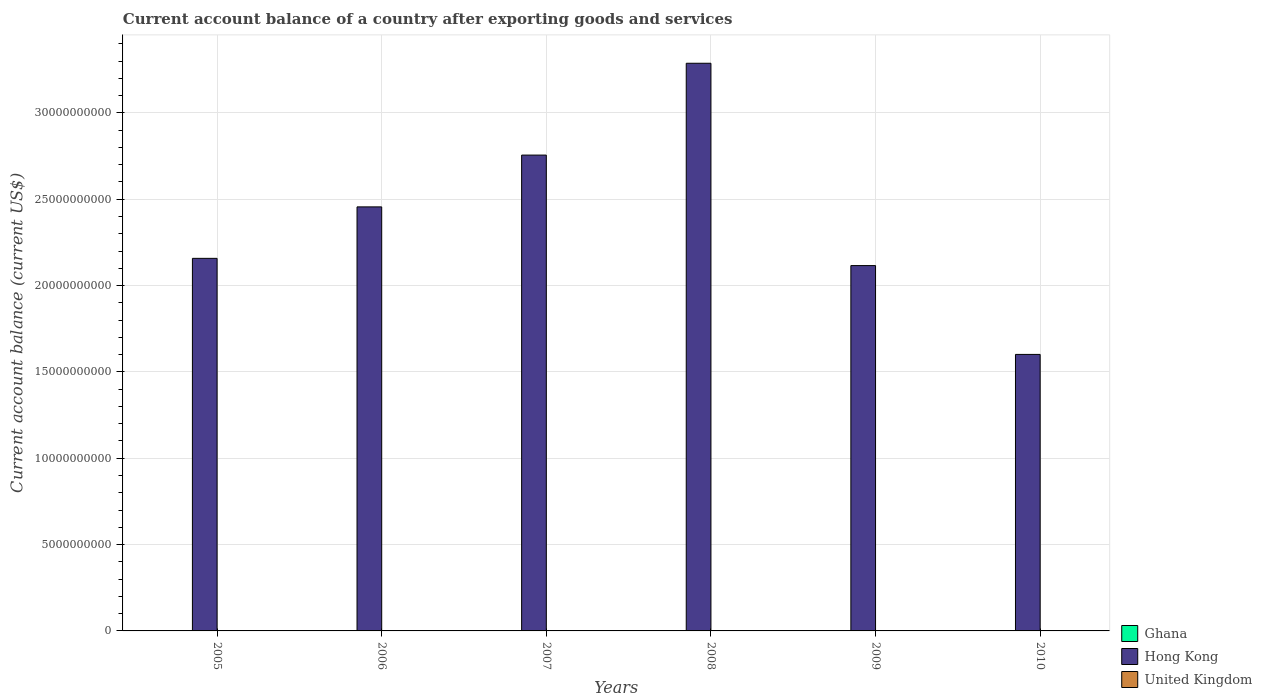How many different coloured bars are there?
Your response must be concise. 1. How many bars are there on the 6th tick from the right?
Your response must be concise. 1. What is the label of the 4th group of bars from the left?
Make the answer very short. 2008. What is the account balance in Hong Kong in 2005?
Your answer should be very brief. 2.16e+1. Across all years, what is the maximum account balance in Hong Kong?
Make the answer very short. 3.29e+1. Across all years, what is the minimum account balance in Hong Kong?
Provide a succinct answer. 1.60e+1. What is the total account balance in Hong Kong in the graph?
Provide a succinct answer. 1.44e+11. What is the difference between the account balance in Hong Kong in 2007 and that in 2009?
Offer a terse response. 6.40e+09. What is the average account balance in Hong Kong per year?
Provide a succinct answer. 2.40e+1. In how many years, is the account balance in Hong Kong greater than 33000000000 US$?
Make the answer very short. 0. What is the ratio of the account balance in Hong Kong in 2005 to that in 2009?
Provide a succinct answer. 1.02. Is the account balance in Hong Kong in 2005 less than that in 2009?
Provide a short and direct response. No. What is the difference between the highest and the second highest account balance in Hong Kong?
Provide a succinct answer. 5.32e+09. What is the difference between the highest and the lowest account balance in Hong Kong?
Offer a very short reply. 1.69e+1. In how many years, is the account balance in Ghana greater than the average account balance in Ghana taken over all years?
Make the answer very short. 0. Is the sum of the account balance in Hong Kong in 2006 and 2009 greater than the maximum account balance in Ghana across all years?
Provide a short and direct response. Yes. Is it the case that in every year, the sum of the account balance in Hong Kong and account balance in United Kingdom is greater than the account balance in Ghana?
Keep it short and to the point. Yes. Are all the bars in the graph horizontal?
Your answer should be compact. No. How many years are there in the graph?
Your response must be concise. 6. What is the difference between two consecutive major ticks on the Y-axis?
Your answer should be very brief. 5.00e+09. Does the graph contain any zero values?
Your answer should be compact. Yes. Does the graph contain grids?
Provide a succinct answer. Yes. Where does the legend appear in the graph?
Keep it short and to the point. Bottom right. How many legend labels are there?
Ensure brevity in your answer.  3. How are the legend labels stacked?
Keep it short and to the point. Vertical. What is the title of the graph?
Offer a terse response. Current account balance of a country after exporting goods and services. What is the label or title of the Y-axis?
Keep it short and to the point. Current account balance (current US$). What is the Current account balance (current US$) in Hong Kong in 2005?
Offer a very short reply. 2.16e+1. What is the Current account balance (current US$) of United Kingdom in 2005?
Provide a short and direct response. 0. What is the Current account balance (current US$) in Ghana in 2006?
Provide a succinct answer. 0. What is the Current account balance (current US$) in Hong Kong in 2006?
Offer a terse response. 2.46e+1. What is the Current account balance (current US$) in Hong Kong in 2007?
Your answer should be very brief. 2.76e+1. What is the Current account balance (current US$) of United Kingdom in 2007?
Make the answer very short. 0. What is the Current account balance (current US$) of Ghana in 2008?
Provide a short and direct response. 0. What is the Current account balance (current US$) in Hong Kong in 2008?
Your response must be concise. 3.29e+1. What is the Current account balance (current US$) in Hong Kong in 2009?
Keep it short and to the point. 2.12e+1. What is the Current account balance (current US$) of United Kingdom in 2009?
Your answer should be compact. 0. What is the Current account balance (current US$) in Ghana in 2010?
Offer a very short reply. 0. What is the Current account balance (current US$) of Hong Kong in 2010?
Your answer should be very brief. 1.60e+1. What is the Current account balance (current US$) in United Kingdom in 2010?
Ensure brevity in your answer.  0. Across all years, what is the maximum Current account balance (current US$) of Hong Kong?
Your answer should be compact. 3.29e+1. Across all years, what is the minimum Current account balance (current US$) in Hong Kong?
Ensure brevity in your answer.  1.60e+1. What is the total Current account balance (current US$) in Ghana in the graph?
Keep it short and to the point. 0. What is the total Current account balance (current US$) in Hong Kong in the graph?
Your answer should be very brief. 1.44e+11. What is the difference between the Current account balance (current US$) of Hong Kong in 2005 and that in 2006?
Provide a succinct answer. -2.98e+09. What is the difference between the Current account balance (current US$) of Hong Kong in 2005 and that in 2007?
Make the answer very short. -5.98e+09. What is the difference between the Current account balance (current US$) in Hong Kong in 2005 and that in 2008?
Provide a succinct answer. -1.13e+1. What is the difference between the Current account balance (current US$) in Hong Kong in 2005 and that in 2009?
Ensure brevity in your answer.  4.19e+08. What is the difference between the Current account balance (current US$) in Hong Kong in 2005 and that in 2010?
Offer a terse response. 5.56e+09. What is the difference between the Current account balance (current US$) in Hong Kong in 2006 and that in 2007?
Give a very brief answer. -3.00e+09. What is the difference between the Current account balance (current US$) in Hong Kong in 2006 and that in 2008?
Your response must be concise. -8.32e+09. What is the difference between the Current account balance (current US$) of Hong Kong in 2006 and that in 2009?
Provide a succinct answer. 3.40e+09. What is the difference between the Current account balance (current US$) in Hong Kong in 2006 and that in 2010?
Offer a very short reply. 8.54e+09. What is the difference between the Current account balance (current US$) in Hong Kong in 2007 and that in 2008?
Your answer should be compact. -5.32e+09. What is the difference between the Current account balance (current US$) of Hong Kong in 2007 and that in 2009?
Give a very brief answer. 6.40e+09. What is the difference between the Current account balance (current US$) in Hong Kong in 2007 and that in 2010?
Make the answer very short. 1.15e+1. What is the difference between the Current account balance (current US$) of Hong Kong in 2008 and that in 2009?
Provide a short and direct response. 1.17e+1. What is the difference between the Current account balance (current US$) of Hong Kong in 2008 and that in 2010?
Give a very brief answer. 1.69e+1. What is the difference between the Current account balance (current US$) of Hong Kong in 2009 and that in 2010?
Provide a succinct answer. 5.14e+09. What is the average Current account balance (current US$) of Ghana per year?
Your answer should be very brief. 0. What is the average Current account balance (current US$) of Hong Kong per year?
Your answer should be compact. 2.40e+1. What is the ratio of the Current account balance (current US$) of Hong Kong in 2005 to that in 2006?
Ensure brevity in your answer.  0.88. What is the ratio of the Current account balance (current US$) of Hong Kong in 2005 to that in 2007?
Give a very brief answer. 0.78. What is the ratio of the Current account balance (current US$) in Hong Kong in 2005 to that in 2008?
Ensure brevity in your answer.  0.66. What is the ratio of the Current account balance (current US$) of Hong Kong in 2005 to that in 2009?
Your answer should be very brief. 1.02. What is the ratio of the Current account balance (current US$) in Hong Kong in 2005 to that in 2010?
Keep it short and to the point. 1.35. What is the ratio of the Current account balance (current US$) in Hong Kong in 2006 to that in 2007?
Your answer should be very brief. 0.89. What is the ratio of the Current account balance (current US$) in Hong Kong in 2006 to that in 2008?
Keep it short and to the point. 0.75. What is the ratio of the Current account balance (current US$) of Hong Kong in 2006 to that in 2009?
Provide a succinct answer. 1.16. What is the ratio of the Current account balance (current US$) of Hong Kong in 2006 to that in 2010?
Provide a succinct answer. 1.53. What is the ratio of the Current account balance (current US$) in Hong Kong in 2007 to that in 2008?
Give a very brief answer. 0.84. What is the ratio of the Current account balance (current US$) in Hong Kong in 2007 to that in 2009?
Your response must be concise. 1.3. What is the ratio of the Current account balance (current US$) of Hong Kong in 2007 to that in 2010?
Provide a short and direct response. 1.72. What is the ratio of the Current account balance (current US$) of Hong Kong in 2008 to that in 2009?
Keep it short and to the point. 1.55. What is the ratio of the Current account balance (current US$) of Hong Kong in 2008 to that in 2010?
Your answer should be compact. 2.05. What is the ratio of the Current account balance (current US$) of Hong Kong in 2009 to that in 2010?
Give a very brief answer. 1.32. What is the difference between the highest and the second highest Current account balance (current US$) of Hong Kong?
Offer a very short reply. 5.32e+09. What is the difference between the highest and the lowest Current account balance (current US$) in Hong Kong?
Ensure brevity in your answer.  1.69e+1. 